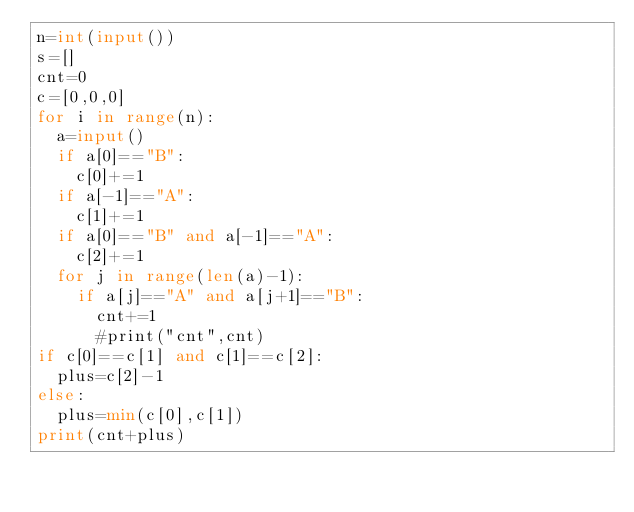Convert code to text. <code><loc_0><loc_0><loc_500><loc_500><_Python_>n=int(input())
s=[]
cnt=0
c=[0,0,0]
for i in range(n):
  a=input()
  if a[0]=="B":
    c[0]+=1
  if a[-1]=="A":
    c[1]+=1
  if a[0]=="B" and a[-1]=="A":
    c[2]+=1
  for j in range(len(a)-1):
    if a[j]=="A" and a[j+1]=="B":
      cnt+=1
      #print("cnt",cnt)
if c[0]==c[1] and c[1]==c[2]:
  plus=c[2]-1
else:
  plus=min(c[0],c[1])
print(cnt+plus)
</code> 